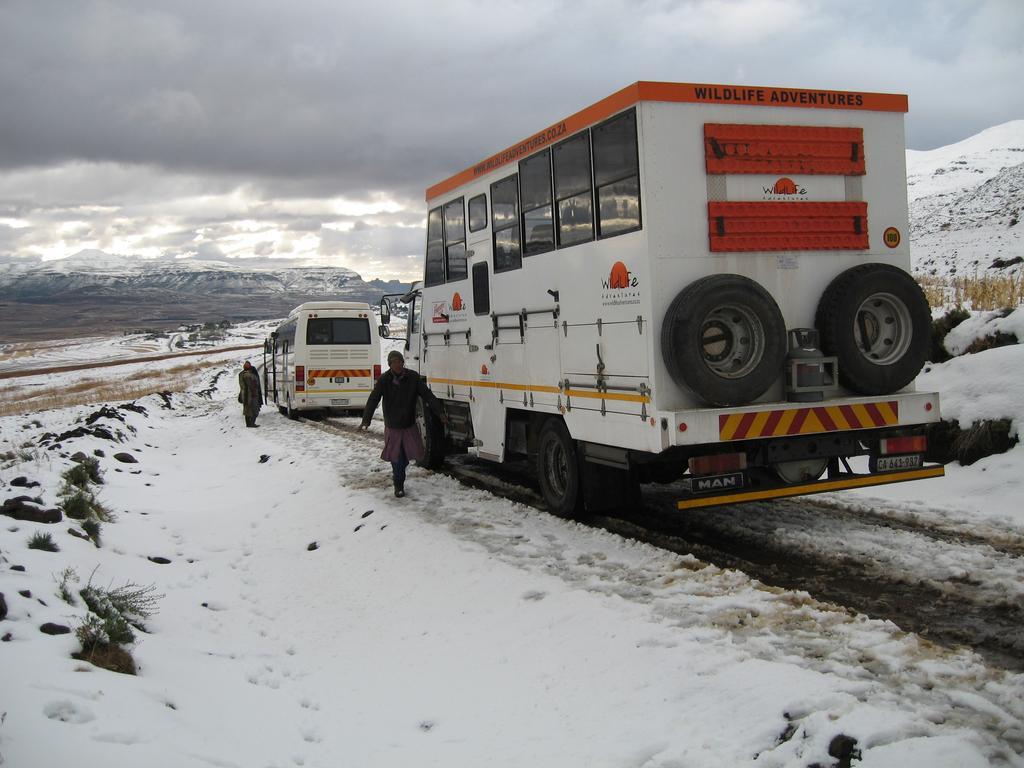Please provide a concise description of this image. In this image we can see two vehicles and people on the land. We can see snow on the land. At the top of the image, we can see the sky covered with clouds. 